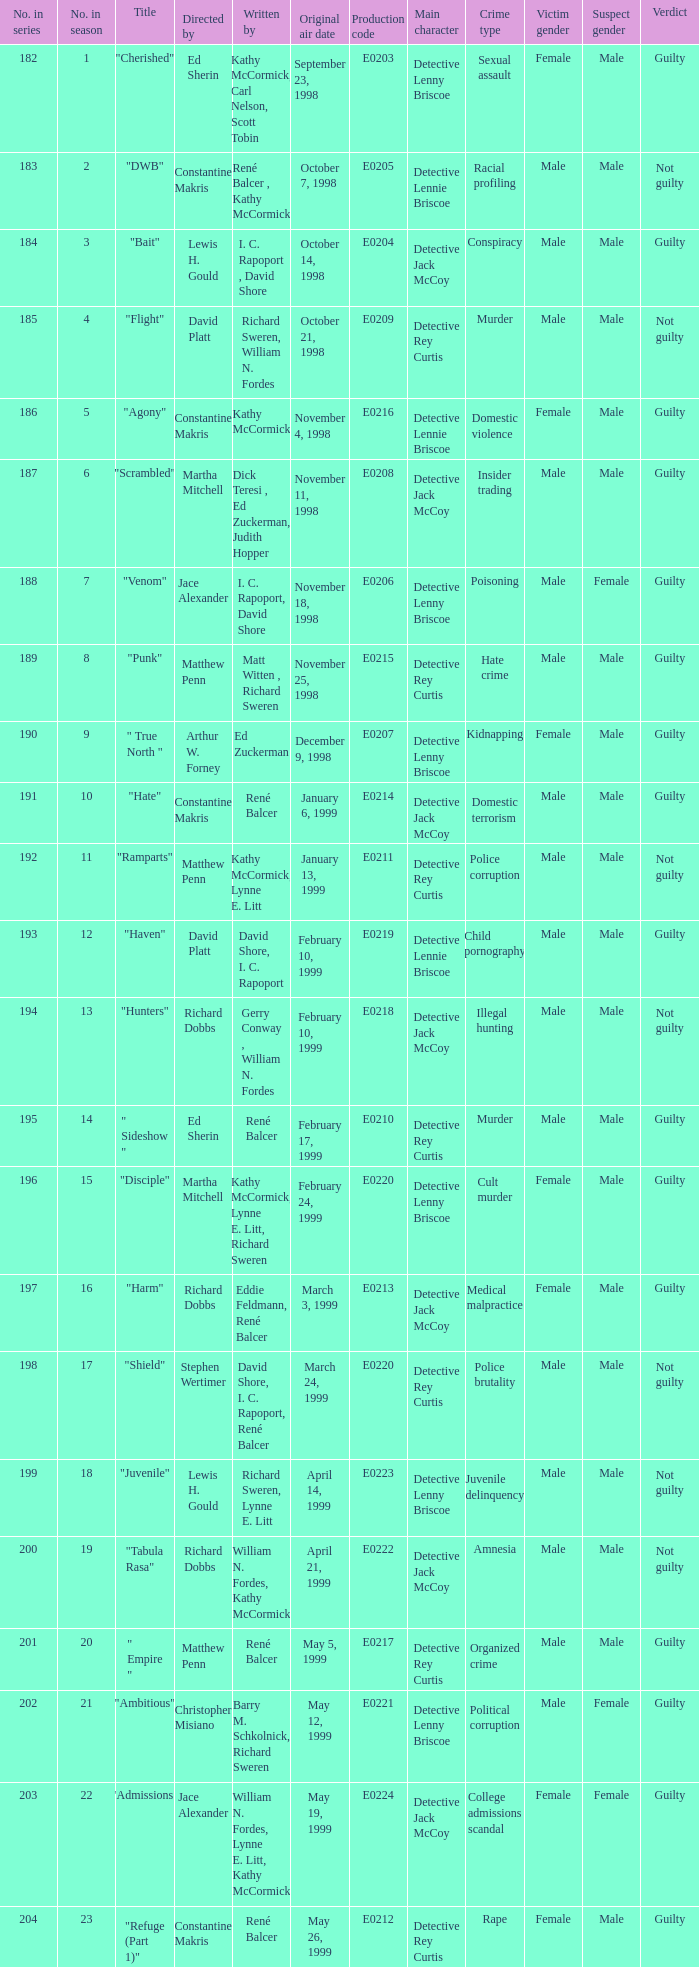What is the season number of the episode written by Matt Witten , Richard Sweren? 8.0. 